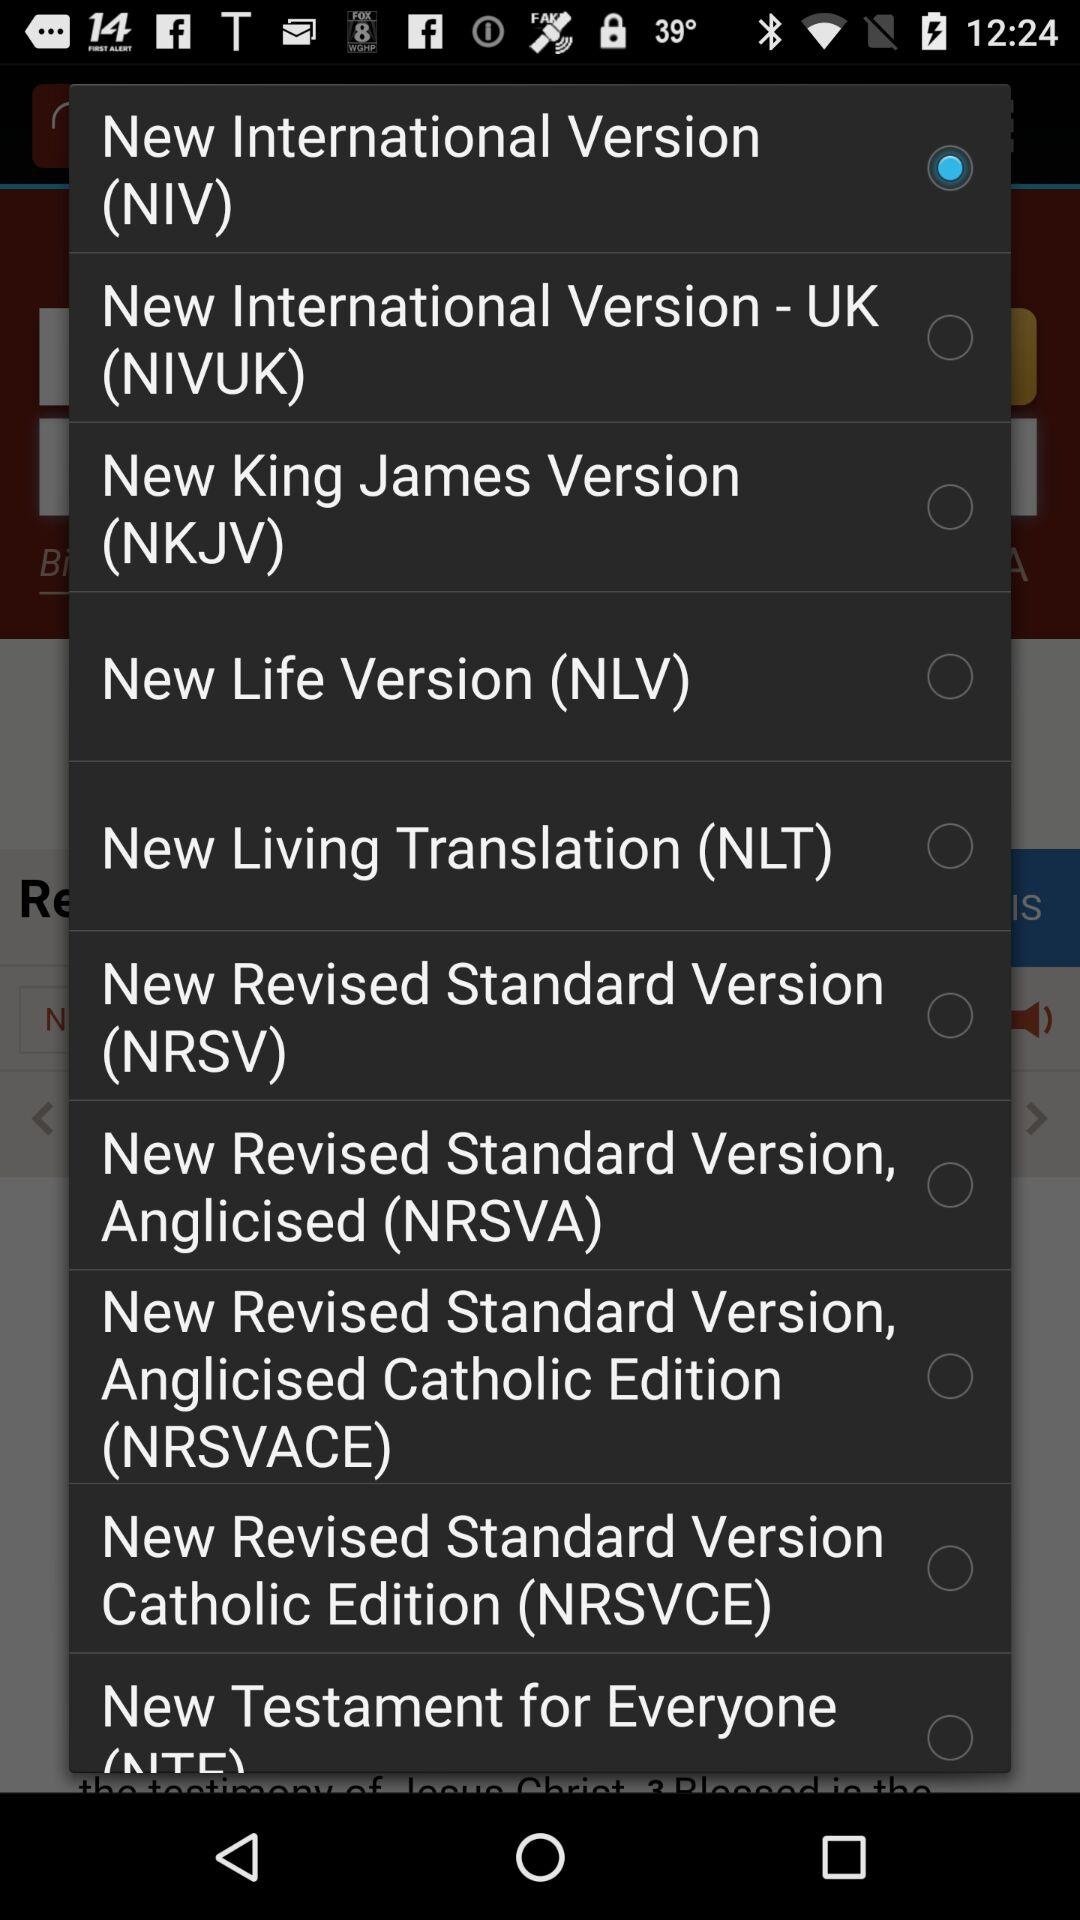Which radio button is selected? The selected radio button is "New International Version (NIV)". 